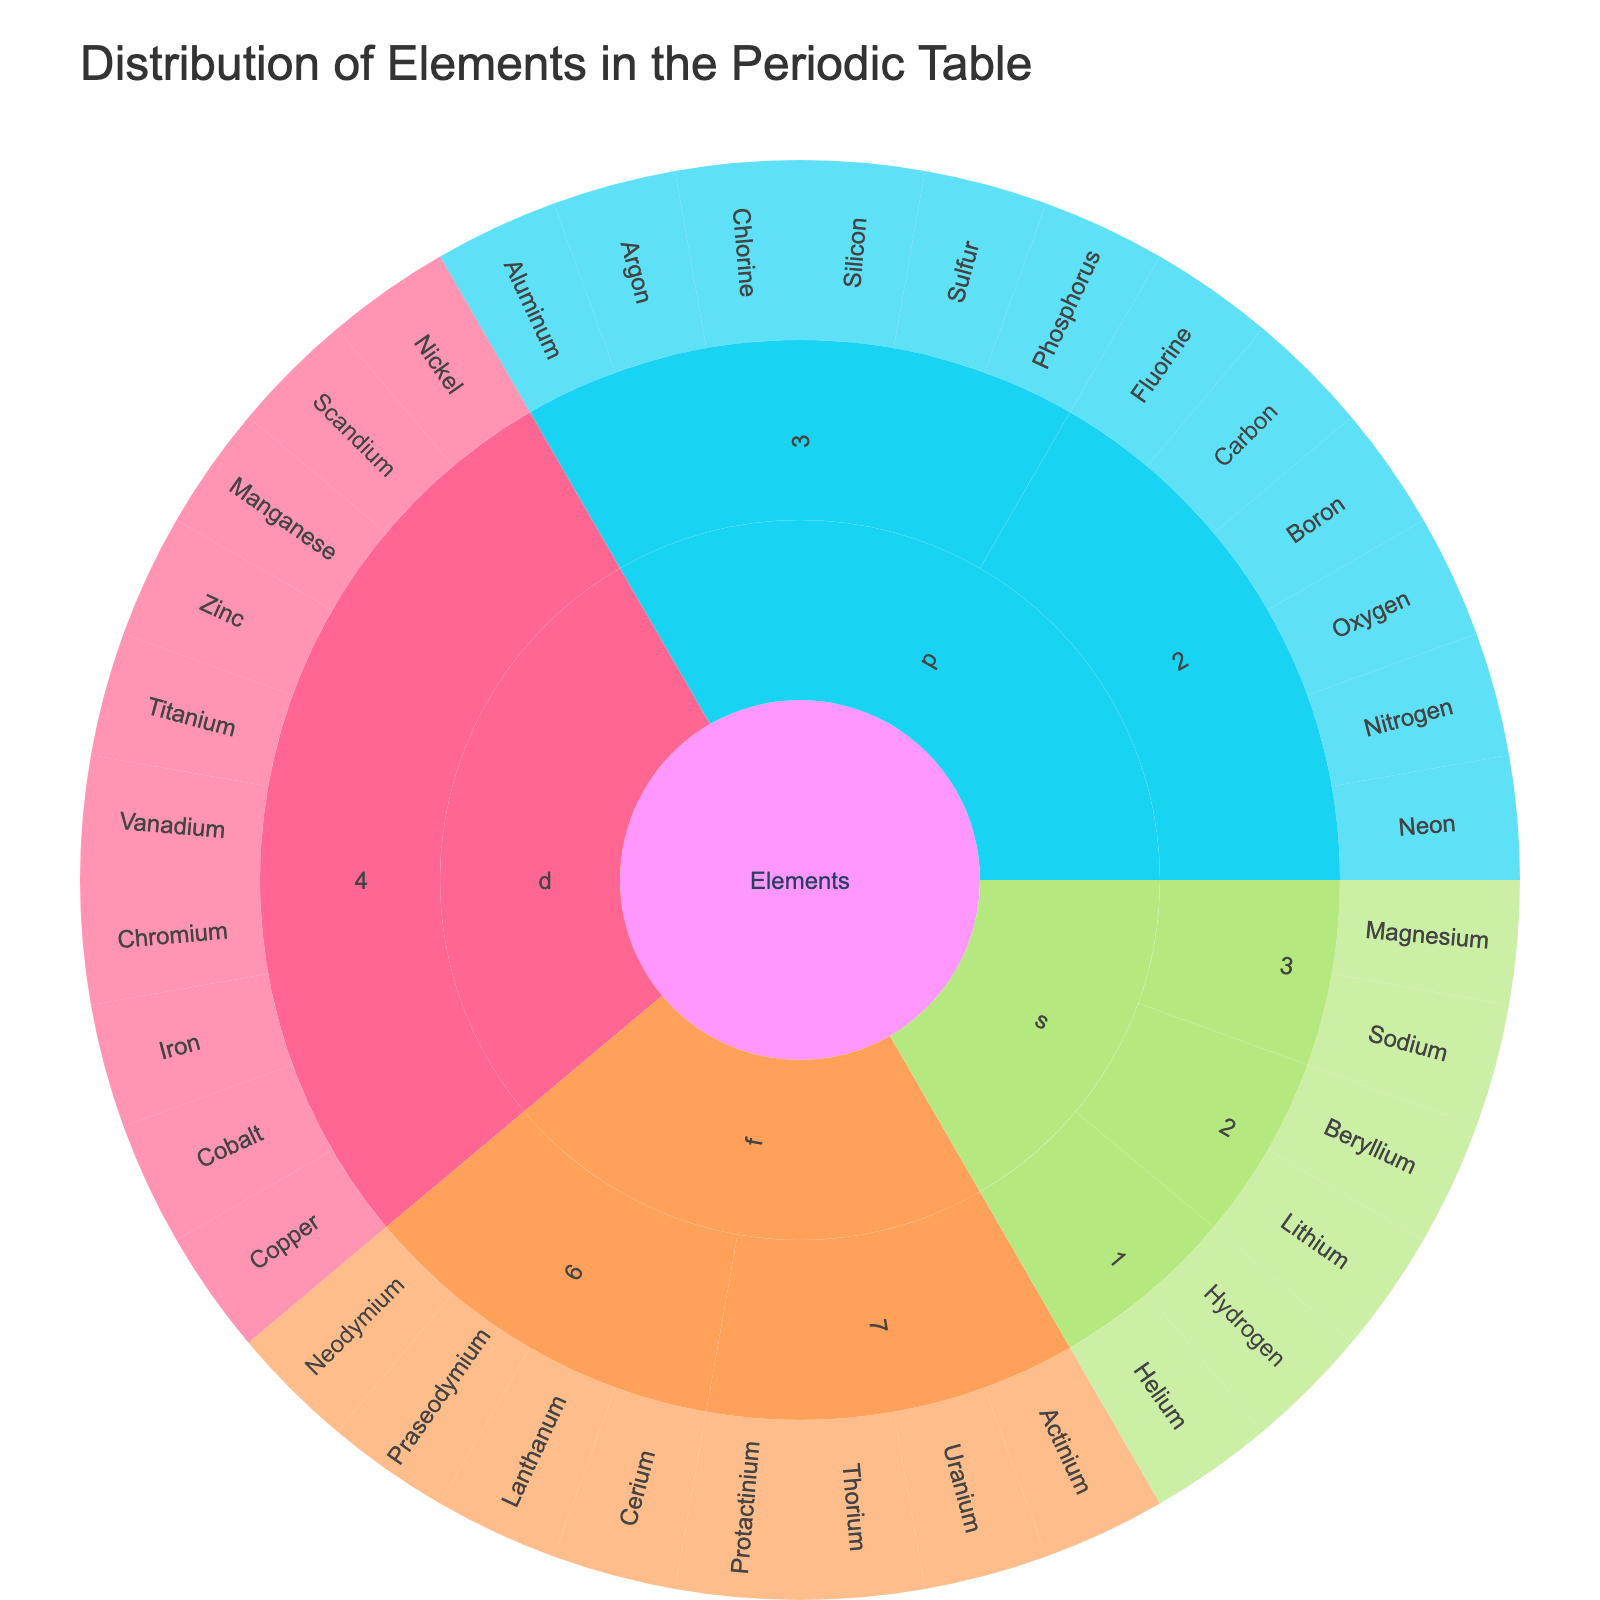What is the title of the sunburst plot? The title is typically found at the top of a figure and provides a brief description of what the plot represents.
Answer: Distribution of Elements in the Periodic Table How many elements are in the s-block of period 2? Start at the 's-block' and locate period 2 in the sunburst plot. Count the elements listed under this section.
Answer: 2 Which block contains the most periods? Examine the sunburst plot and count the number of periods within each block. Compare these counts to determine which block has the highest number.
Answer: p-block Which period has more elements, period 3 or period 4? Count the number of elements under period 3 and period 4. Compare the two counts to see which is greater.
Answer: Period 3 What is the color used to represent the d-block? Identify the colors used in the plot. Look for the block labeled 'd-block' and note its color.
Answer: Green In which period is Thorium located? Navigate to the 'f-block' and identify the period where Thorium is listed. This period label gives the exact location.
Answer: 7 Compare the number of elements in the p-block of period 2 to the s-block of period 2. Which has more? Count the number of elements in the p-block of period 2 and the s-block of period 2. Compare the counts to determine which is larger.
Answer: p-block of period 2 How many elements are there in the f-block summed across all periods? Identify the sections for the f-block. Count all elements listed under the periods within f-block and sum these values.
Answer: 8 Are there more elements in the s-block of period 1 or the  s-block of period 3? Count the elements in the s-block of period 1 and period 3. Compare these counts to determine which is higher.
Answer: s-block of period 3 Which element is located in the d-block of period 4 and starts with the letter 'I'? Navigate to the d-block and identify period 4. Look through the elements for one that starts with 'I'.
Answer: Iron 